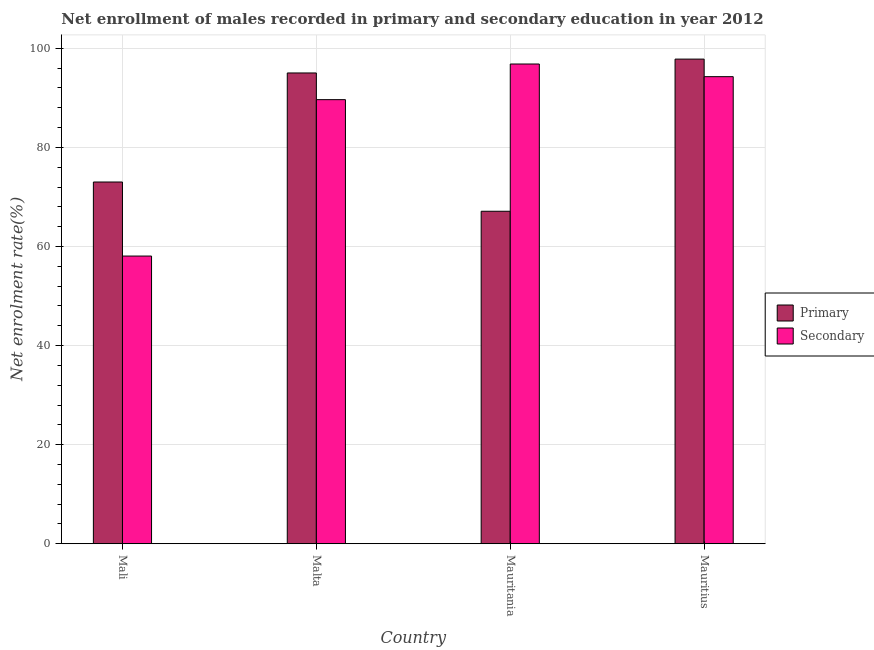How many groups of bars are there?
Make the answer very short. 4. Are the number of bars per tick equal to the number of legend labels?
Make the answer very short. Yes. How many bars are there on the 4th tick from the left?
Provide a succinct answer. 2. What is the label of the 1st group of bars from the left?
Make the answer very short. Mali. What is the enrollment rate in secondary education in Mali?
Make the answer very short. 58.07. Across all countries, what is the maximum enrollment rate in primary education?
Ensure brevity in your answer.  97.83. Across all countries, what is the minimum enrollment rate in primary education?
Keep it short and to the point. 67.12. In which country was the enrollment rate in secondary education maximum?
Ensure brevity in your answer.  Mauritania. In which country was the enrollment rate in primary education minimum?
Provide a short and direct response. Mauritania. What is the total enrollment rate in secondary education in the graph?
Your answer should be compact. 338.83. What is the difference between the enrollment rate in secondary education in Mauritania and that in Mauritius?
Your answer should be very brief. 2.55. What is the difference between the enrollment rate in primary education in Mauritania and the enrollment rate in secondary education in Mauritius?
Offer a very short reply. -27.17. What is the average enrollment rate in primary education per country?
Your answer should be very brief. 83.25. What is the difference between the enrollment rate in primary education and enrollment rate in secondary education in Mali?
Provide a succinct answer. 14.95. In how many countries, is the enrollment rate in primary education greater than 16 %?
Provide a short and direct response. 4. What is the ratio of the enrollment rate in primary education in Malta to that in Mauritius?
Give a very brief answer. 0.97. Is the enrollment rate in primary education in Mali less than that in Mauritius?
Offer a very short reply. Yes. What is the difference between the highest and the second highest enrollment rate in secondary education?
Offer a terse response. 2.55. What is the difference between the highest and the lowest enrollment rate in primary education?
Keep it short and to the point. 30.71. In how many countries, is the enrollment rate in primary education greater than the average enrollment rate in primary education taken over all countries?
Keep it short and to the point. 2. Is the sum of the enrollment rate in secondary education in Mauritania and Mauritius greater than the maximum enrollment rate in primary education across all countries?
Your response must be concise. Yes. What does the 2nd bar from the left in Mauritania represents?
Make the answer very short. Secondary. What does the 2nd bar from the right in Mauritius represents?
Ensure brevity in your answer.  Primary. How many bars are there?
Offer a very short reply. 8. What is the difference between two consecutive major ticks on the Y-axis?
Your answer should be compact. 20. Does the graph contain grids?
Your answer should be compact. Yes. How many legend labels are there?
Offer a terse response. 2. What is the title of the graph?
Ensure brevity in your answer.  Net enrollment of males recorded in primary and secondary education in year 2012. What is the label or title of the X-axis?
Provide a succinct answer. Country. What is the label or title of the Y-axis?
Offer a very short reply. Net enrolment rate(%). What is the Net enrolment rate(%) in Primary in Mali?
Your answer should be compact. 73.02. What is the Net enrolment rate(%) in Secondary in Mali?
Keep it short and to the point. 58.07. What is the Net enrolment rate(%) of Primary in Malta?
Offer a terse response. 95.03. What is the Net enrolment rate(%) in Secondary in Malta?
Make the answer very short. 89.64. What is the Net enrolment rate(%) in Primary in Mauritania?
Give a very brief answer. 67.12. What is the Net enrolment rate(%) of Secondary in Mauritania?
Give a very brief answer. 96.84. What is the Net enrolment rate(%) in Primary in Mauritius?
Keep it short and to the point. 97.83. What is the Net enrolment rate(%) in Secondary in Mauritius?
Offer a terse response. 94.28. Across all countries, what is the maximum Net enrolment rate(%) of Primary?
Make the answer very short. 97.83. Across all countries, what is the maximum Net enrolment rate(%) in Secondary?
Offer a terse response. 96.84. Across all countries, what is the minimum Net enrolment rate(%) of Primary?
Your answer should be very brief. 67.12. Across all countries, what is the minimum Net enrolment rate(%) of Secondary?
Keep it short and to the point. 58.07. What is the total Net enrolment rate(%) in Primary in the graph?
Your answer should be compact. 332.99. What is the total Net enrolment rate(%) in Secondary in the graph?
Provide a succinct answer. 338.83. What is the difference between the Net enrolment rate(%) in Primary in Mali and that in Malta?
Give a very brief answer. -22.01. What is the difference between the Net enrolment rate(%) of Secondary in Mali and that in Malta?
Your response must be concise. -31.57. What is the difference between the Net enrolment rate(%) in Primary in Mali and that in Mauritania?
Offer a terse response. 5.9. What is the difference between the Net enrolment rate(%) of Secondary in Mali and that in Mauritania?
Make the answer very short. -38.77. What is the difference between the Net enrolment rate(%) of Primary in Mali and that in Mauritius?
Your answer should be compact. -24.81. What is the difference between the Net enrolment rate(%) in Secondary in Mali and that in Mauritius?
Provide a succinct answer. -36.21. What is the difference between the Net enrolment rate(%) of Primary in Malta and that in Mauritania?
Offer a terse response. 27.91. What is the difference between the Net enrolment rate(%) in Secondary in Malta and that in Mauritania?
Make the answer very short. -7.19. What is the difference between the Net enrolment rate(%) of Primary in Malta and that in Mauritius?
Offer a very short reply. -2.8. What is the difference between the Net enrolment rate(%) in Secondary in Malta and that in Mauritius?
Keep it short and to the point. -4.64. What is the difference between the Net enrolment rate(%) of Primary in Mauritania and that in Mauritius?
Your answer should be compact. -30.71. What is the difference between the Net enrolment rate(%) in Secondary in Mauritania and that in Mauritius?
Ensure brevity in your answer.  2.55. What is the difference between the Net enrolment rate(%) of Primary in Mali and the Net enrolment rate(%) of Secondary in Malta?
Your answer should be compact. -16.62. What is the difference between the Net enrolment rate(%) of Primary in Mali and the Net enrolment rate(%) of Secondary in Mauritania?
Offer a terse response. -23.82. What is the difference between the Net enrolment rate(%) in Primary in Mali and the Net enrolment rate(%) in Secondary in Mauritius?
Keep it short and to the point. -21.26. What is the difference between the Net enrolment rate(%) of Primary in Malta and the Net enrolment rate(%) of Secondary in Mauritania?
Your answer should be very brief. -1.81. What is the difference between the Net enrolment rate(%) of Primary in Malta and the Net enrolment rate(%) of Secondary in Mauritius?
Your answer should be very brief. 0.75. What is the difference between the Net enrolment rate(%) of Primary in Mauritania and the Net enrolment rate(%) of Secondary in Mauritius?
Offer a very short reply. -27.17. What is the average Net enrolment rate(%) of Primary per country?
Provide a short and direct response. 83.25. What is the average Net enrolment rate(%) in Secondary per country?
Make the answer very short. 84.71. What is the difference between the Net enrolment rate(%) of Primary and Net enrolment rate(%) of Secondary in Mali?
Your response must be concise. 14.95. What is the difference between the Net enrolment rate(%) in Primary and Net enrolment rate(%) in Secondary in Malta?
Your answer should be compact. 5.39. What is the difference between the Net enrolment rate(%) of Primary and Net enrolment rate(%) of Secondary in Mauritania?
Give a very brief answer. -29.72. What is the difference between the Net enrolment rate(%) in Primary and Net enrolment rate(%) in Secondary in Mauritius?
Your response must be concise. 3.54. What is the ratio of the Net enrolment rate(%) in Primary in Mali to that in Malta?
Make the answer very short. 0.77. What is the ratio of the Net enrolment rate(%) in Secondary in Mali to that in Malta?
Offer a terse response. 0.65. What is the ratio of the Net enrolment rate(%) of Primary in Mali to that in Mauritania?
Keep it short and to the point. 1.09. What is the ratio of the Net enrolment rate(%) in Secondary in Mali to that in Mauritania?
Keep it short and to the point. 0.6. What is the ratio of the Net enrolment rate(%) of Primary in Mali to that in Mauritius?
Provide a short and direct response. 0.75. What is the ratio of the Net enrolment rate(%) of Secondary in Mali to that in Mauritius?
Make the answer very short. 0.62. What is the ratio of the Net enrolment rate(%) in Primary in Malta to that in Mauritania?
Give a very brief answer. 1.42. What is the ratio of the Net enrolment rate(%) in Secondary in Malta to that in Mauritania?
Offer a terse response. 0.93. What is the ratio of the Net enrolment rate(%) in Primary in Malta to that in Mauritius?
Give a very brief answer. 0.97. What is the ratio of the Net enrolment rate(%) of Secondary in Malta to that in Mauritius?
Make the answer very short. 0.95. What is the ratio of the Net enrolment rate(%) in Primary in Mauritania to that in Mauritius?
Provide a short and direct response. 0.69. What is the ratio of the Net enrolment rate(%) of Secondary in Mauritania to that in Mauritius?
Give a very brief answer. 1.03. What is the difference between the highest and the second highest Net enrolment rate(%) of Primary?
Your answer should be very brief. 2.8. What is the difference between the highest and the second highest Net enrolment rate(%) in Secondary?
Your response must be concise. 2.55. What is the difference between the highest and the lowest Net enrolment rate(%) in Primary?
Provide a succinct answer. 30.71. What is the difference between the highest and the lowest Net enrolment rate(%) in Secondary?
Provide a short and direct response. 38.77. 